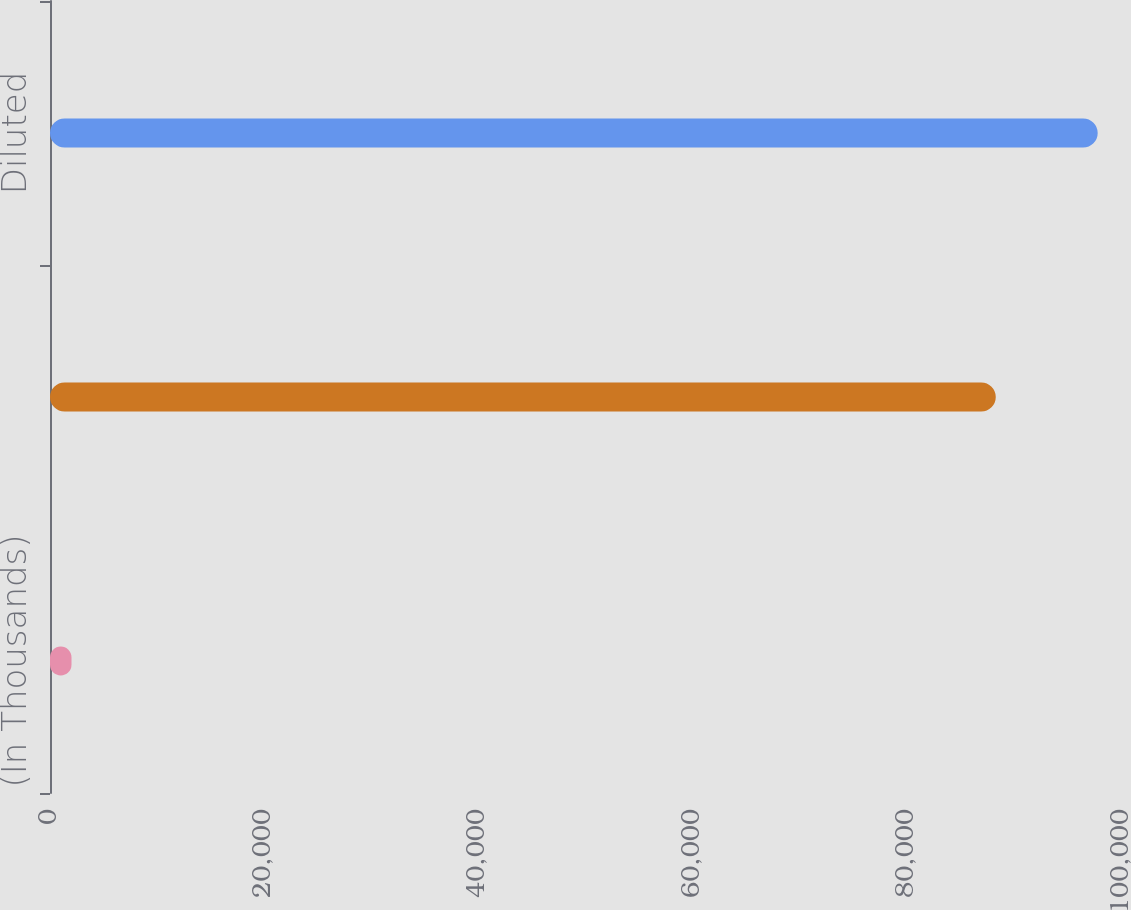Convert chart to OTSL. <chart><loc_0><loc_0><loc_500><loc_500><bar_chart><fcel>(In Thousands)<fcel>Basic<fcel>Diluted<nl><fcel>2005<fcel>88224<fcel>97732.4<nl></chart> 